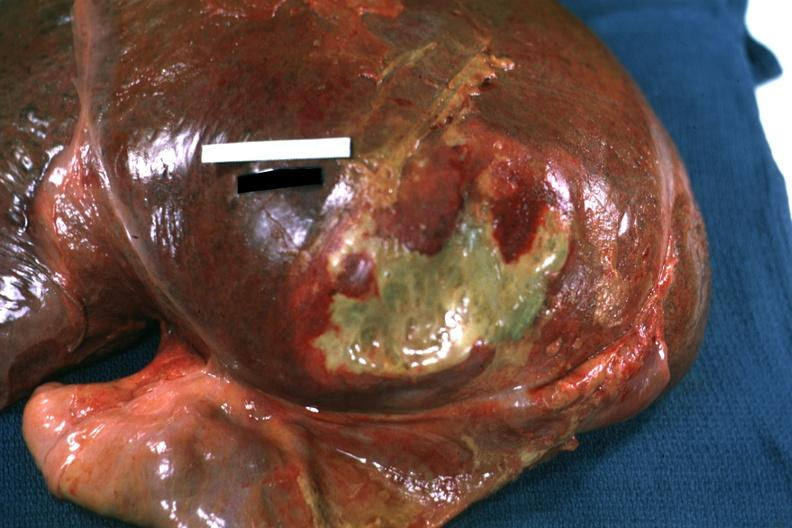what is present?
Answer the question using a single word or phrase. Hepatobiliary 